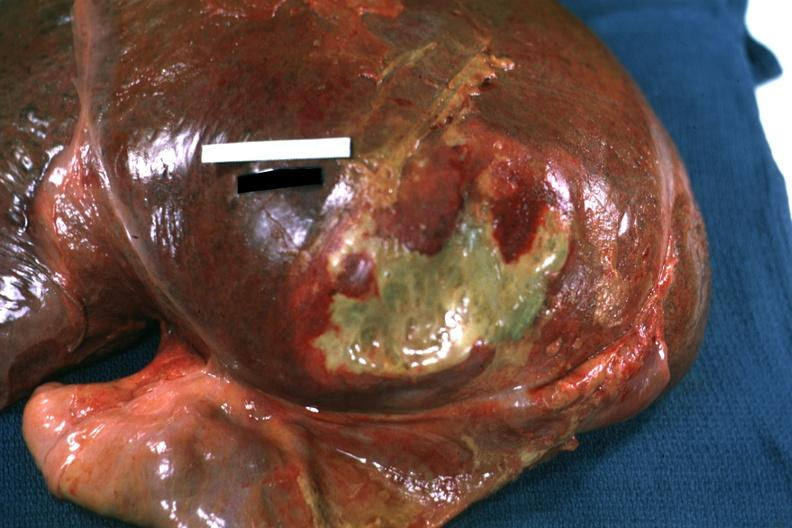what is present?
Answer the question using a single word or phrase. Hepatobiliary 